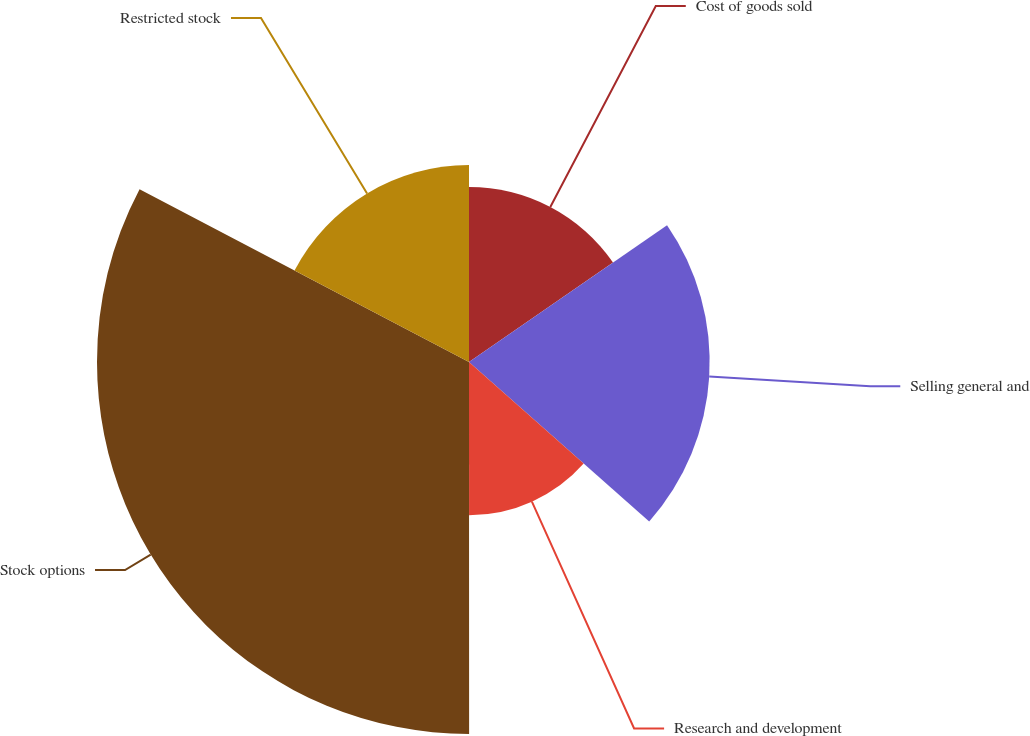<chart> <loc_0><loc_0><loc_500><loc_500><pie_chart><fcel>Cost of goods sold<fcel>Selling general and<fcel>Research and development<fcel>Stock options<fcel>Restricted stock<nl><fcel>15.38%<fcel>21.15%<fcel>13.46%<fcel>32.69%<fcel>17.31%<nl></chart> 